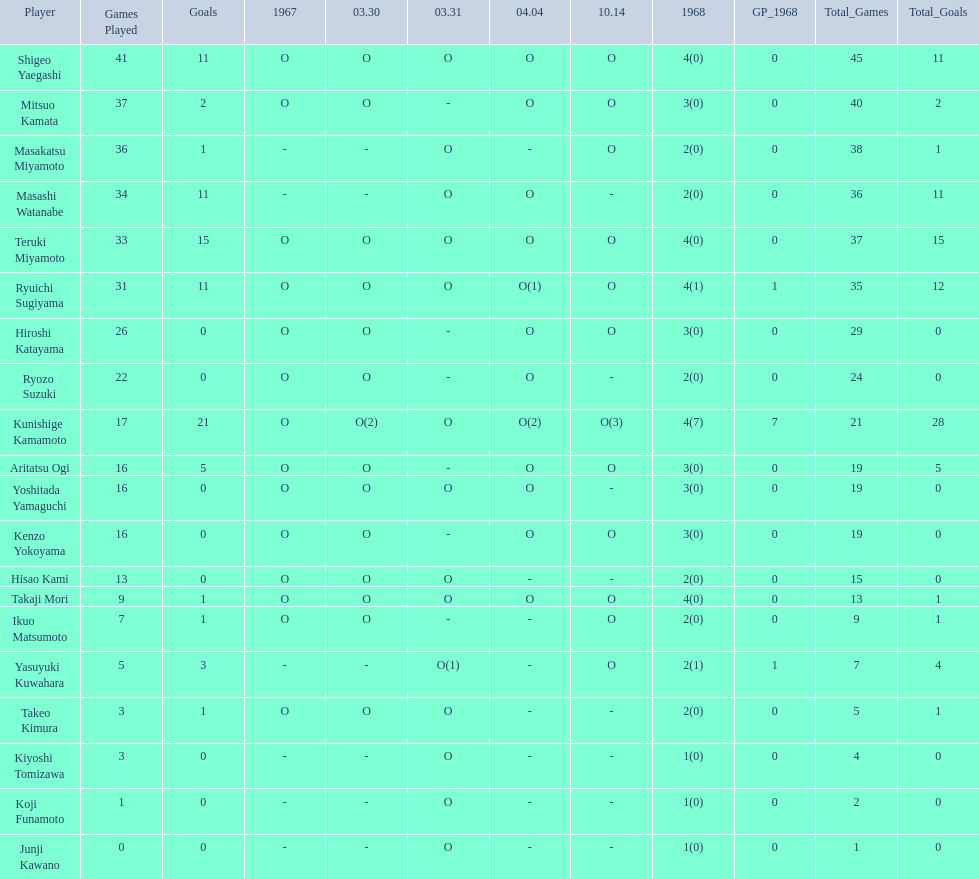Who were the players in the 1968 japanese football? Shigeo Yaegashi, Mitsuo Kamata, Masakatsu Miyamoto, Masashi Watanabe, Teruki Miyamoto, Ryuichi Sugiyama, Hiroshi Katayama, Ryozo Suzuki, Kunishige Kamamoto, Aritatsu Ogi, Yoshitada Yamaguchi, Kenzo Yokoyama, Hisao Kami, Takaji Mori, Ikuo Matsumoto, Yasuyuki Kuwahara, Takeo Kimura, Kiyoshi Tomizawa, Koji Funamoto, Junji Kawano. How many points total did takaji mori have? 13(1). How many points total did junju kawano? 1(0). Who had more points? Takaji Mori. 